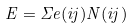Convert formula to latex. <formula><loc_0><loc_0><loc_500><loc_500>E = \Sigma e ( i j ) N ( i j )</formula> 